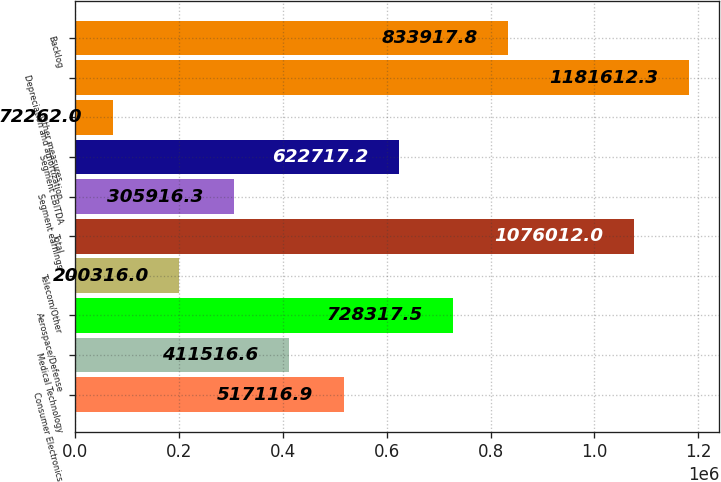<chart> <loc_0><loc_0><loc_500><loc_500><bar_chart><fcel>Consumer Electronics<fcel>Medical Technology<fcel>Aerospace/Defense<fcel>Telecom/Other<fcel>Total<fcel>Segment earnings<fcel>Segment EBITDA<fcel>Other measures<fcel>Depreciation and amortization<fcel>Backlog<nl><fcel>517117<fcel>411517<fcel>728318<fcel>200316<fcel>1.07601e+06<fcel>305916<fcel>622717<fcel>72262<fcel>1.18161e+06<fcel>833918<nl></chart> 